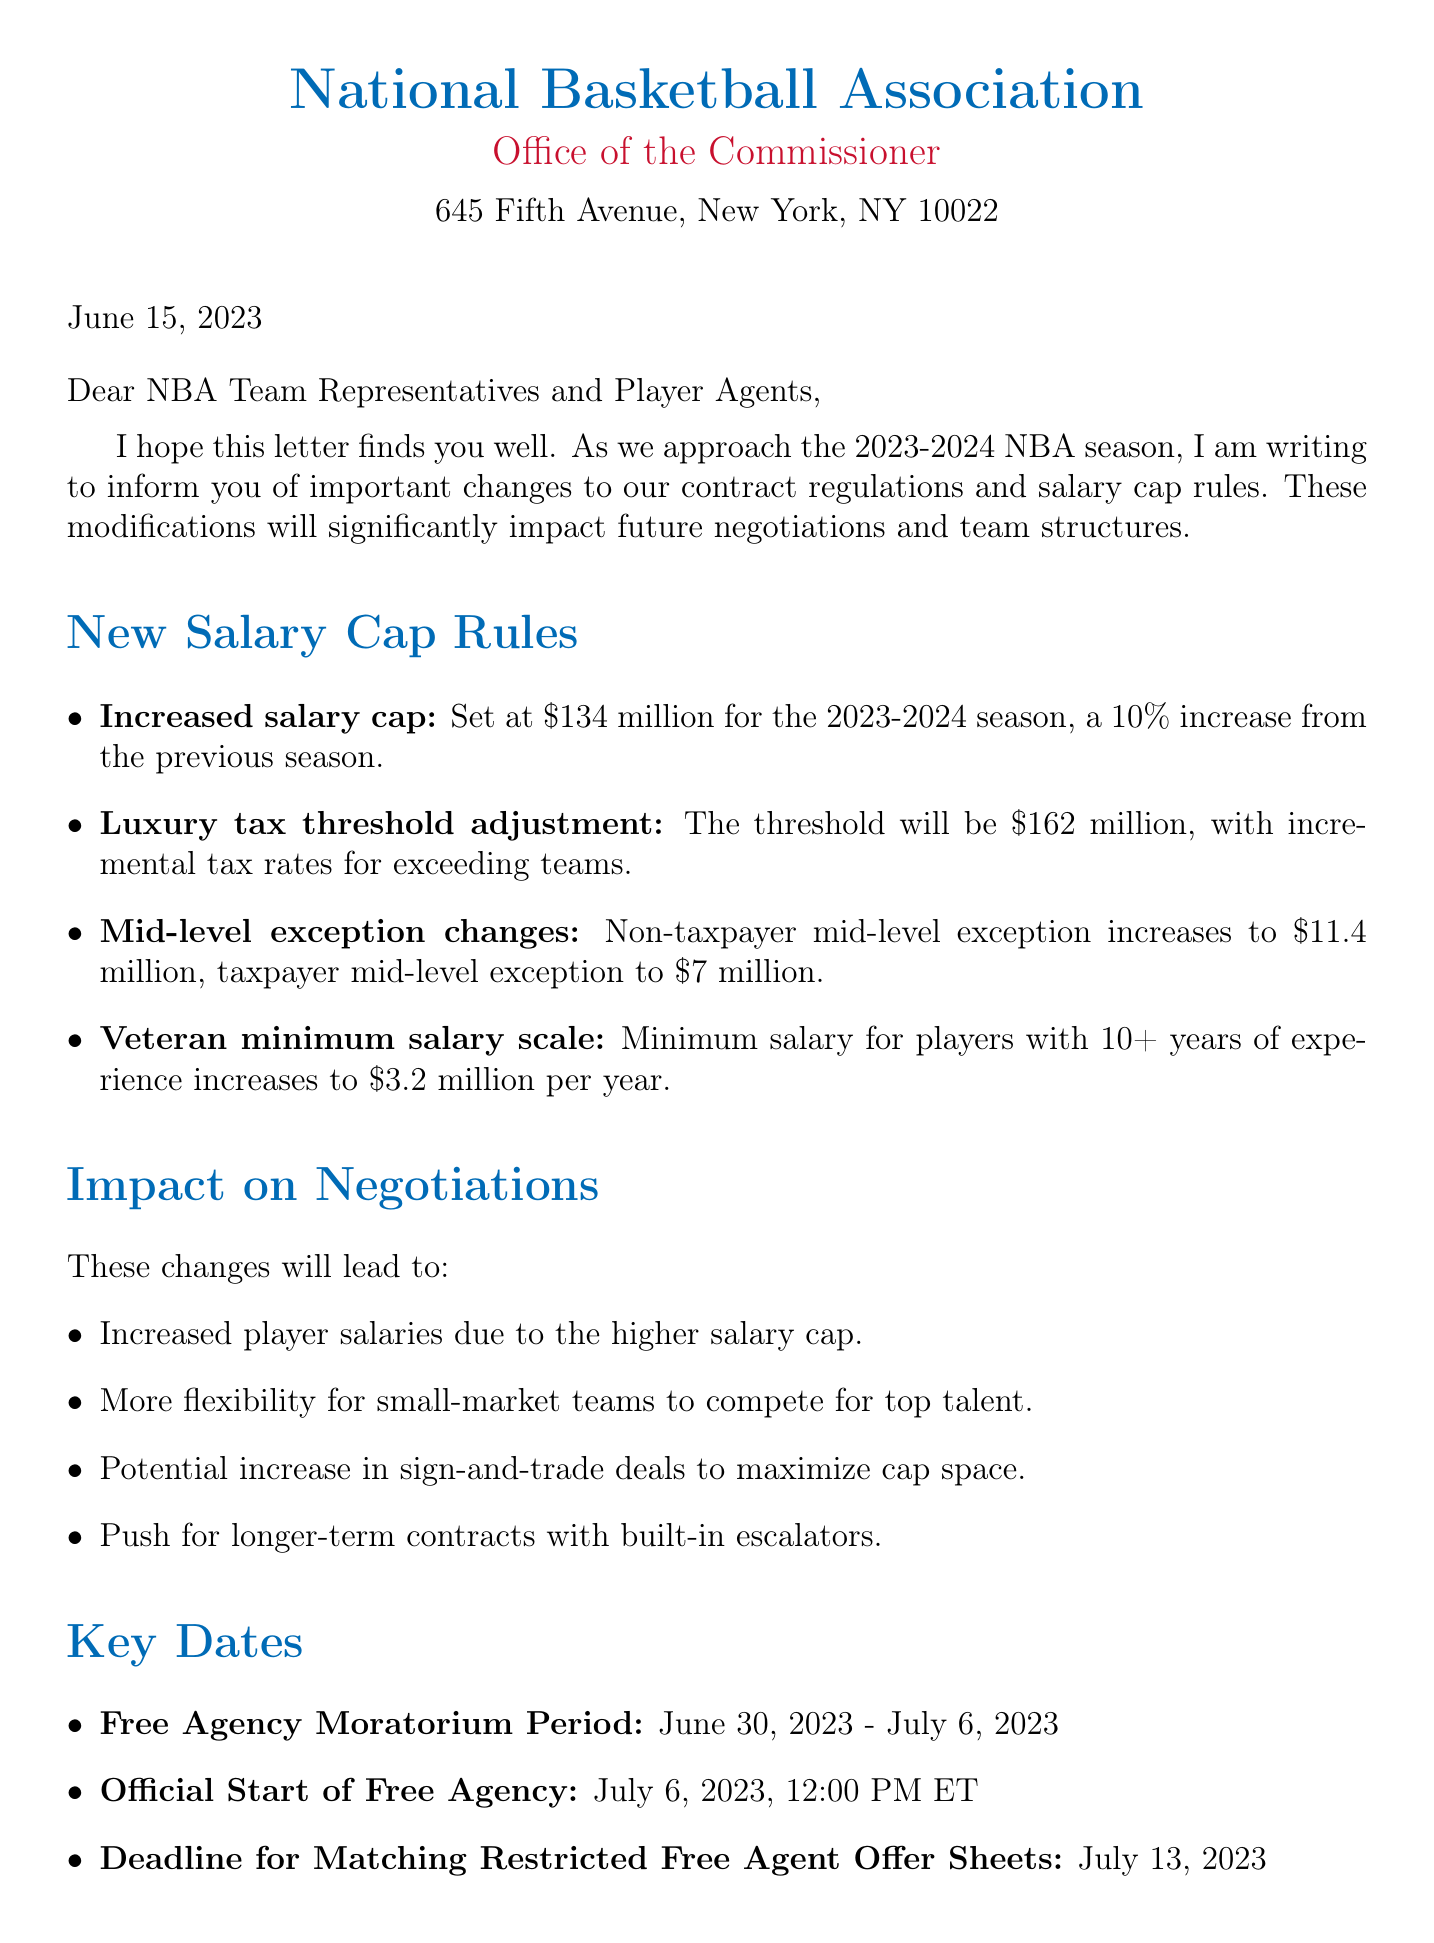What is the date of the notification letter? The date of the notification letter is explicitly stated in the document.
Answer: June 15, 2023 What is the new salary cap for the 2023-2024 season? The document provides the specific amount of the increased salary cap.
Answer: $134 million What is the luxury tax threshold for the upcoming season? The document specifies the amount for the luxury tax threshold.
Answer: $162 million What is the increased amount of the non-taxpayer mid-level exception? The document mentions the new amount for the non-taxpayer mid-level exception.
Answer: $11.4 million Which team will face higher penalties for exceeding the luxury tax threshold? The document identifies a specific team that will be impacted by the luxury tax penalties.
Answer: Los Angeles Lakers How long is the Free Agency Moratorium Period? The document outlines the dates of the Free Agency Moratorium Period, revealing its duration.
Answer: June 30, 2023 - July 6, 2023 What impact will the new rules have on small-market teams? The document explains the benefits the new salary cap rules will provide to small-market teams.
Answer: More flexibility What potential strategy may teams utilize more frequently due to salary cap changes? The document suggests a possible approach teams might adopt concerning player transactions.
Answer: Sign-and-trade deals Who should be contacted for further clarification regarding these changes? The document provides contact information for inquiries about the new rules.
Answer: NBA Player Relations 